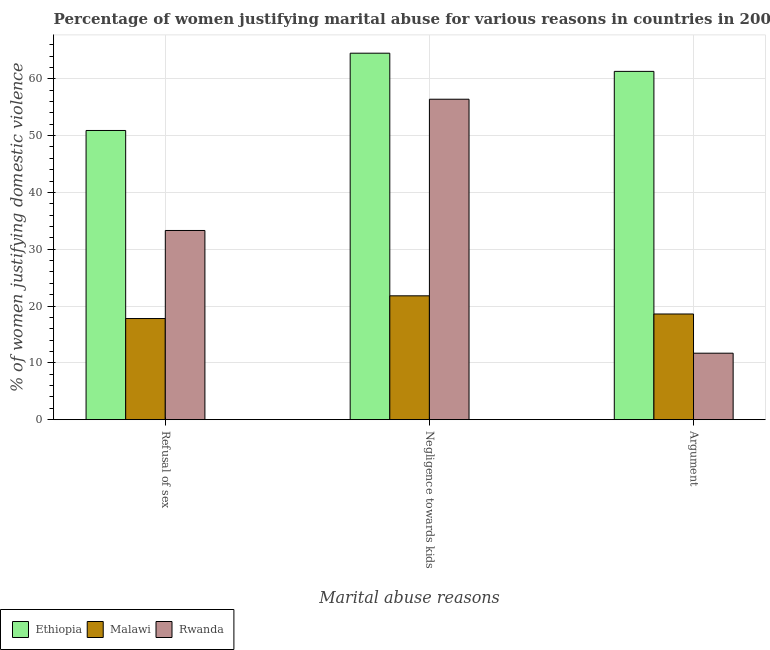How many different coloured bars are there?
Keep it short and to the point. 3. How many groups of bars are there?
Your answer should be very brief. 3. Are the number of bars on each tick of the X-axis equal?
Your response must be concise. Yes. How many bars are there on the 2nd tick from the left?
Offer a very short reply. 3. What is the label of the 2nd group of bars from the left?
Provide a short and direct response. Negligence towards kids. What is the percentage of women justifying domestic violence due to negligence towards kids in Malawi?
Offer a terse response. 21.8. Across all countries, what is the maximum percentage of women justifying domestic violence due to negligence towards kids?
Give a very brief answer. 64.5. Across all countries, what is the minimum percentage of women justifying domestic violence due to refusal of sex?
Ensure brevity in your answer.  17.8. In which country was the percentage of women justifying domestic violence due to negligence towards kids maximum?
Your answer should be very brief. Ethiopia. In which country was the percentage of women justifying domestic violence due to refusal of sex minimum?
Your answer should be very brief. Malawi. What is the total percentage of women justifying domestic violence due to arguments in the graph?
Ensure brevity in your answer.  91.6. What is the difference between the percentage of women justifying domestic violence due to arguments in Ethiopia and that in Malawi?
Provide a short and direct response. 42.7. What is the difference between the percentage of women justifying domestic violence due to refusal of sex in Rwanda and the percentage of women justifying domestic violence due to negligence towards kids in Ethiopia?
Provide a short and direct response. -31.2. What is the average percentage of women justifying domestic violence due to negligence towards kids per country?
Make the answer very short. 47.57. What is the difference between the percentage of women justifying domestic violence due to arguments and percentage of women justifying domestic violence due to refusal of sex in Ethiopia?
Your answer should be compact. 10.4. What is the ratio of the percentage of women justifying domestic violence due to refusal of sex in Ethiopia to that in Malawi?
Your response must be concise. 2.86. What is the difference between the highest and the lowest percentage of women justifying domestic violence due to refusal of sex?
Your answer should be compact. 33.1. In how many countries, is the percentage of women justifying domestic violence due to refusal of sex greater than the average percentage of women justifying domestic violence due to refusal of sex taken over all countries?
Provide a short and direct response. 1. What does the 3rd bar from the left in Argument represents?
Offer a very short reply. Rwanda. What does the 2nd bar from the right in Negligence towards kids represents?
Provide a succinct answer. Malawi. Is it the case that in every country, the sum of the percentage of women justifying domestic violence due to refusal of sex and percentage of women justifying domestic violence due to negligence towards kids is greater than the percentage of women justifying domestic violence due to arguments?
Make the answer very short. Yes. How many bars are there?
Provide a succinct answer. 9. Are all the bars in the graph horizontal?
Keep it short and to the point. No. What is the difference between two consecutive major ticks on the Y-axis?
Your response must be concise. 10. How many legend labels are there?
Give a very brief answer. 3. How are the legend labels stacked?
Give a very brief answer. Horizontal. What is the title of the graph?
Give a very brief answer. Percentage of women justifying marital abuse for various reasons in countries in 2000. What is the label or title of the X-axis?
Offer a very short reply. Marital abuse reasons. What is the label or title of the Y-axis?
Ensure brevity in your answer.  % of women justifying domestic violence. What is the % of women justifying domestic violence in Ethiopia in Refusal of sex?
Offer a very short reply. 50.9. What is the % of women justifying domestic violence of Malawi in Refusal of sex?
Your answer should be compact. 17.8. What is the % of women justifying domestic violence of Rwanda in Refusal of sex?
Offer a very short reply. 33.3. What is the % of women justifying domestic violence of Ethiopia in Negligence towards kids?
Make the answer very short. 64.5. What is the % of women justifying domestic violence of Malawi in Negligence towards kids?
Offer a terse response. 21.8. What is the % of women justifying domestic violence of Rwanda in Negligence towards kids?
Ensure brevity in your answer.  56.4. What is the % of women justifying domestic violence in Ethiopia in Argument?
Provide a succinct answer. 61.3. What is the % of women justifying domestic violence in Rwanda in Argument?
Make the answer very short. 11.7. Across all Marital abuse reasons, what is the maximum % of women justifying domestic violence of Ethiopia?
Make the answer very short. 64.5. Across all Marital abuse reasons, what is the maximum % of women justifying domestic violence in Malawi?
Give a very brief answer. 21.8. Across all Marital abuse reasons, what is the maximum % of women justifying domestic violence of Rwanda?
Provide a succinct answer. 56.4. Across all Marital abuse reasons, what is the minimum % of women justifying domestic violence of Ethiopia?
Your answer should be very brief. 50.9. Across all Marital abuse reasons, what is the minimum % of women justifying domestic violence in Malawi?
Provide a short and direct response. 17.8. What is the total % of women justifying domestic violence of Ethiopia in the graph?
Provide a short and direct response. 176.7. What is the total % of women justifying domestic violence in Malawi in the graph?
Give a very brief answer. 58.2. What is the total % of women justifying domestic violence of Rwanda in the graph?
Ensure brevity in your answer.  101.4. What is the difference between the % of women justifying domestic violence of Rwanda in Refusal of sex and that in Negligence towards kids?
Offer a terse response. -23.1. What is the difference between the % of women justifying domestic violence in Malawi in Refusal of sex and that in Argument?
Keep it short and to the point. -0.8. What is the difference between the % of women justifying domestic violence in Rwanda in Refusal of sex and that in Argument?
Your response must be concise. 21.6. What is the difference between the % of women justifying domestic violence of Ethiopia in Negligence towards kids and that in Argument?
Provide a succinct answer. 3.2. What is the difference between the % of women justifying domestic violence in Rwanda in Negligence towards kids and that in Argument?
Your response must be concise. 44.7. What is the difference between the % of women justifying domestic violence in Ethiopia in Refusal of sex and the % of women justifying domestic violence in Malawi in Negligence towards kids?
Ensure brevity in your answer.  29.1. What is the difference between the % of women justifying domestic violence in Ethiopia in Refusal of sex and the % of women justifying domestic violence in Rwanda in Negligence towards kids?
Your response must be concise. -5.5. What is the difference between the % of women justifying domestic violence of Malawi in Refusal of sex and the % of women justifying domestic violence of Rwanda in Negligence towards kids?
Offer a terse response. -38.6. What is the difference between the % of women justifying domestic violence in Ethiopia in Refusal of sex and the % of women justifying domestic violence in Malawi in Argument?
Your answer should be very brief. 32.3. What is the difference between the % of women justifying domestic violence in Ethiopia in Refusal of sex and the % of women justifying domestic violence in Rwanda in Argument?
Your answer should be compact. 39.2. What is the difference between the % of women justifying domestic violence in Malawi in Refusal of sex and the % of women justifying domestic violence in Rwanda in Argument?
Offer a very short reply. 6.1. What is the difference between the % of women justifying domestic violence in Ethiopia in Negligence towards kids and the % of women justifying domestic violence in Malawi in Argument?
Make the answer very short. 45.9. What is the difference between the % of women justifying domestic violence in Ethiopia in Negligence towards kids and the % of women justifying domestic violence in Rwanda in Argument?
Offer a terse response. 52.8. What is the average % of women justifying domestic violence in Ethiopia per Marital abuse reasons?
Offer a very short reply. 58.9. What is the average % of women justifying domestic violence in Rwanda per Marital abuse reasons?
Your answer should be compact. 33.8. What is the difference between the % of women justifying domestic violence of Ethiopia and % of women justifying domestic violence of Malawi in Refusal of sex?
Keep it short and to the point. 33.1. What is the difference between the % of women justifying domestic violence in Malawi and % of women justifying domestic violence in Rwanda in Refusal of sex?
Make the answer very short. -15.5. What is the difference between the % of women justifying domestic violence of Ethiopia and % of women justifying domestic violence of Malawi in Negligence towards kids?
Your response must be concise. 42.7. What is the difference between the % of women justifying domestic violence of Ethiopia and % of women justifying domestic violence of Rwanda in Negligence towards kids?
Ensure brevity in your answer.  8.1. What is the difference between the % of women justifying domestic violence in Malawi and % of women justifying domestic violence in Rwanda in Negligence towards kids?
Your answer should be very brief. -34.6. What is the difference between the % of women justifying domestic violence of Ethiopia and % of women justifying domestic violence of Malawi in Argument?
Offer a terse response. 42.7. What is the difference between the % of women justifying domestic violence of Ethiopia and % of women justifying domestic violence of Rwanda in Argument?
Your answer should be very brief. 49.6. What is the ratio of the % of women justifying domestic violence in Ethiopia in Refusal of sex to that in Negligence towards kids?
Ensure brevity in your answer.  0.79. What is the ratio of the % of women justifying domestic violence of Malawi in Refusal of sex to that in Negligence towards kids?
Your response must be concise. 0.82. What is the ratio of the % of women justifying domestic violence of Rwanda in Refusal of sex to that in Negligence towards kids?
Provide a succinct answer. 0.59. What is the ratio of the % of women justifying domestic violence of Ethiopia in Refusal of sex to that in Argument?
Offer a very short reply. 0.83. What is the ratio of the % of women justifying domestic violence of Malawi in Refusal of sex to that in Argument?
Provide a succinct answer. 0.96. What is the ratio of the % of women justifying domestic violence in Rwanda in Refusal of sex to that in Argument?
Your answer should be compact. 2.85. What is the ratio of the % of women justifying domestic violence of Ethiopia in Negligence towards kids to that in Argument?
Keep it short and to the point. 1.05. What is the ratio of the % of women justifying domestic violence in Malawi in Negligence towards kids to that in Argument?
Ensure brevity in your answer.  1.17. What is the ratio of the % of women justifying domestic violence in Rwanda in Negligence towards kids to that in Argument?
Your response must be concise. 4.82. What is the difference between the highest and the second highest % of women justifying domestic violence of Rwanda?
Your answer should be compact. 23.1. What is the difference between the highest and the lowest % of women justifying domestic violence in Ethiopia?
Give a very brief answer. 13.6. What is the difference between the highest and the lowest % of women justifying domestic violence in Malawi?
Offer a very short reply. 4. What is the difference between the highest and the lowest % of women justifying domestic violence in Rwanda?
Provide a short and direct response. 44.7. 